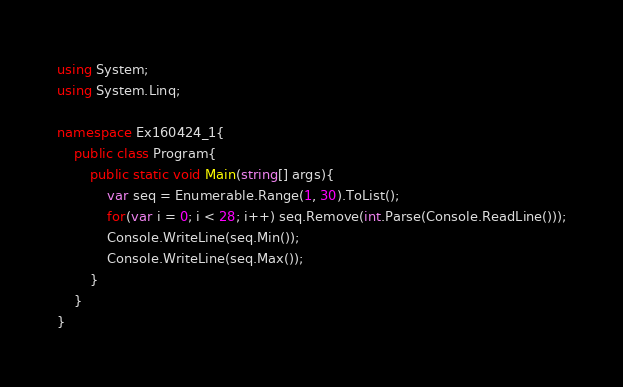Convert code to text. <code><loc_0><loc_0><loc_500><loc_500><_C#_>using System;
using System.Linq;

namespace Ex160424_1{
    public class Program{
        public static void Main(string[] args){
            var seq = Enumerable.Range(1, 30).ToList();
            for(var i = 0; i < 28; i++) seq.Remove(int.Parse(Console.ReadLine()));
            Console.WriteLine(seq.Min());
            Console.WriteLine(seq.Max());
        }
    }
}</code> 